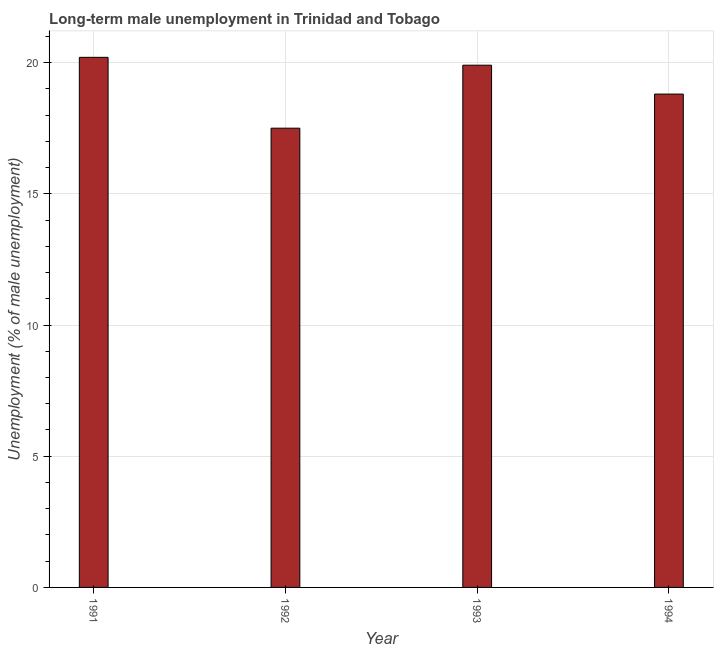Does the graph contain any zero values?
Your response must be concise. No. What is the title of the graph?
Keep it short and to the point. Long-term male unemployment in Trinidad and Tobago. What is the label or title of the Y-axis?
Provide a succinct answer. Unemployment (% of male unemployment). What is the long-term male unemployment in 1993?
Ensure brevity in your answer.  19.9. Across all years, what is the maximum long-term male unemployment?
Keep it short and to the point. 20.2. In which year was the long-term male unemployment maximum?
Make the answer very short. 1991. In which year was the long-term male unemployment minimum?
Give a very brief answer. 1992. What is the sum of the long-term male unemployment?
Your answer should be compact. 76.4. What is the median long-term male unemployment?
Keep it short and to the point. 19.35. Do a majority of the years between 1991 and 1992 (inclusive) have long-term male unemployment greater than 5 %?
Offer a terse response. Yes. What is the ratio of the long-term male unemployment in 1991 to that in 1994?
Your answer should be very brief. 1.07. Is the difference between the long-term male unemployment in 1991 and 1993 greater than the difference between any two years?
Offer a terse response. No. What is the difference between the highest and the second highest long-term male unemployment?
Make the answer very short. 0.3. What is the difference between the highest and the lowest long-term male unemployment?
Make the answer very short. 2.7. In how many years, is the long-term male unemployment greater than the average long-term male unemployment taken over all years?
Make the answer very short. 2. How many bars are there?
Make the answer very short. 4. How many years are there in the graph?
Make the answer very short. 4. What is the difference between two consecutive major ticks on the Y-axis?
Give a very brief answer. 5. What is the Unemployment (% of male unemployment) of 1991?
Keep it short and to the point. 20.2. What is the Unemployment (% of male unemployment) of 1993?
Offer a terse response. 19.9. What is the Unemployment (% of male unemployment) of 1994?
Offer a terse response. 18.8. What is the difference between the Unemployment (% of male unemployment) in 1991 and 1993?
Provide a succinct answer. 0.3. What is the difference between the Unemployment (% of male unemployment) in 1993 and 1994?
Offer a very short reply. 1.1. What is the ratio of the Unemployment (% of male unemployment) in 1991 to that in 1992?
Offer a terse response. 1.15. What is the ratio of the Unemployment (% of male unemployment) in 1991 to that in 1993?
Give a very brief answer. 1.01. What is the ratio of the Unemployment (% of male unemployment) in 1991 to that in 1994?
Make the answer very short. 1.07. What is the ratio of the Unemployment (% of male unemployment) in 1992 to that in 1993?
Make the answer very short. 0.88. What is the ratio of the Unemployment (% of male unemployment) in 1993 to that in 1994?
Your response must be concise. 1.06. 